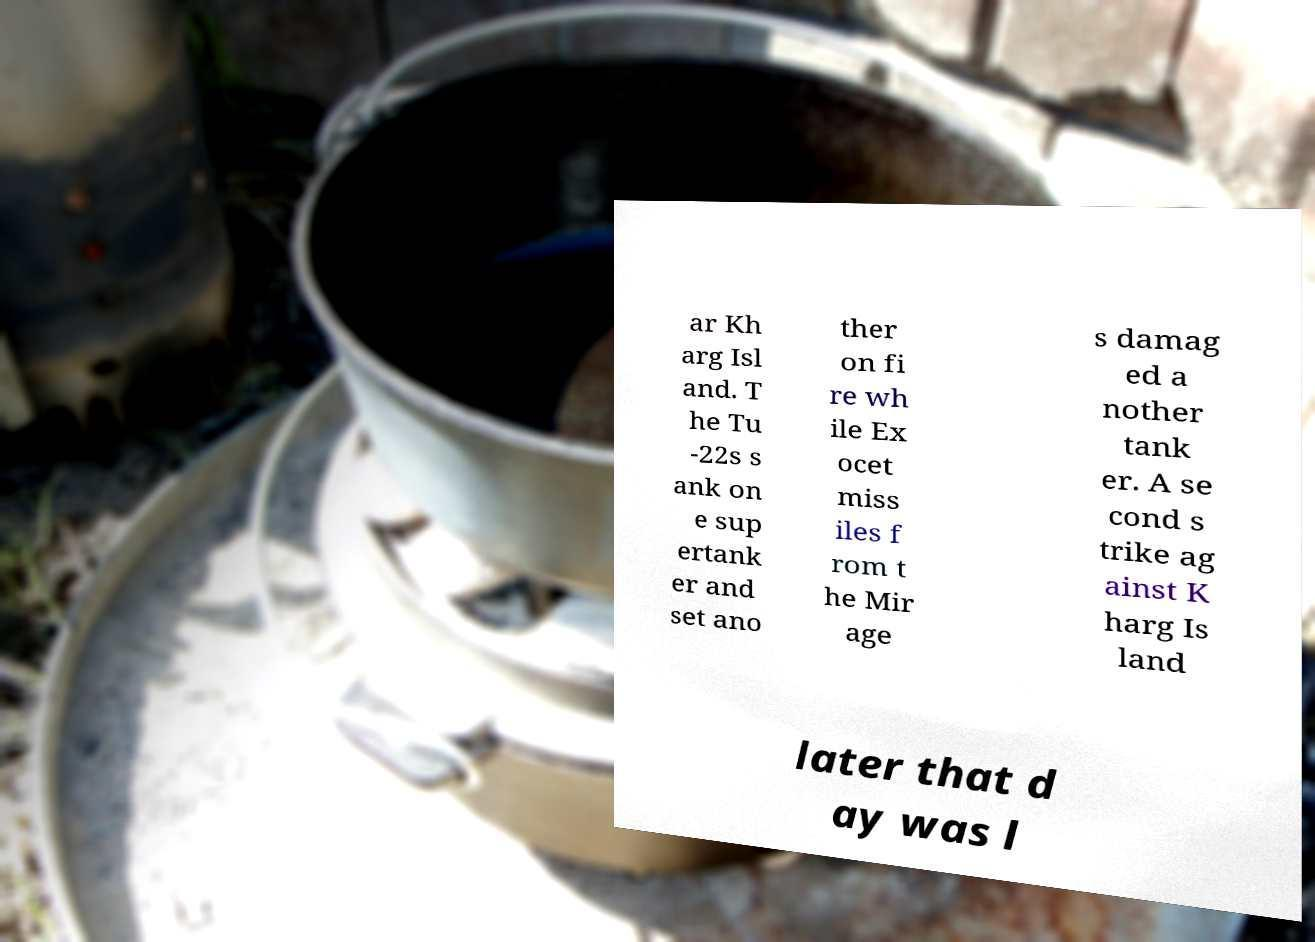Please read and relay the text visible in this image. What does it say? ar Kh arg Isl and. T he Tu -22s s ank on e sup ertank er and set ano ther on fi re wh ile Ex ocet miss iles f rom t he Mir age s damag ed a nother tank er. A se cond s trike ag ainst K harg Is land later that d ay was l 